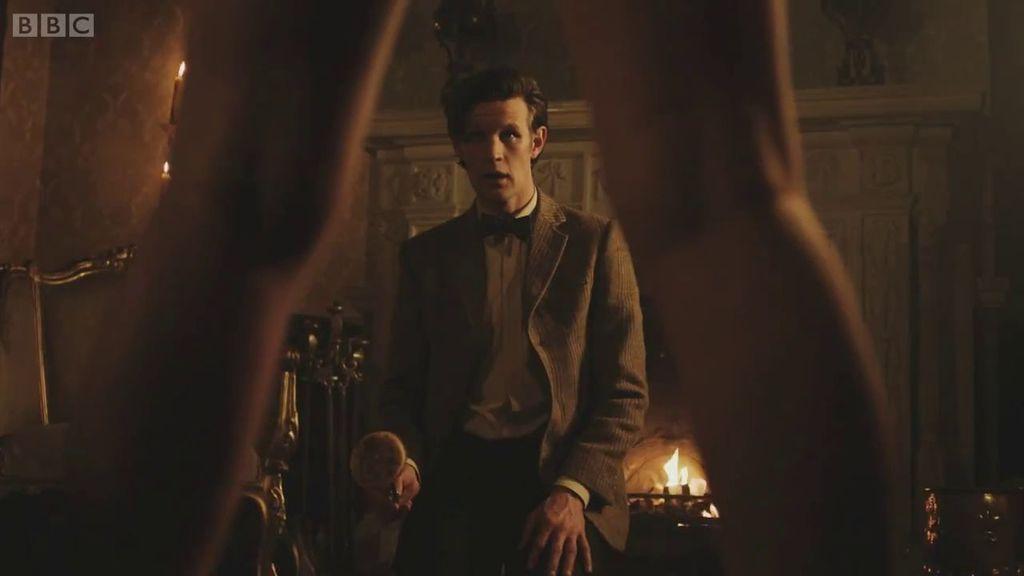In one or two sentences, can you explain what this image depicts? In the picture we can see a man standing near the table, he is in a blazer, tie and shirt and in front of him we can see a woman legs from it, we can see a man and beside the man we can see a light and on the other side we can see a part of the chair and some things are placed. 